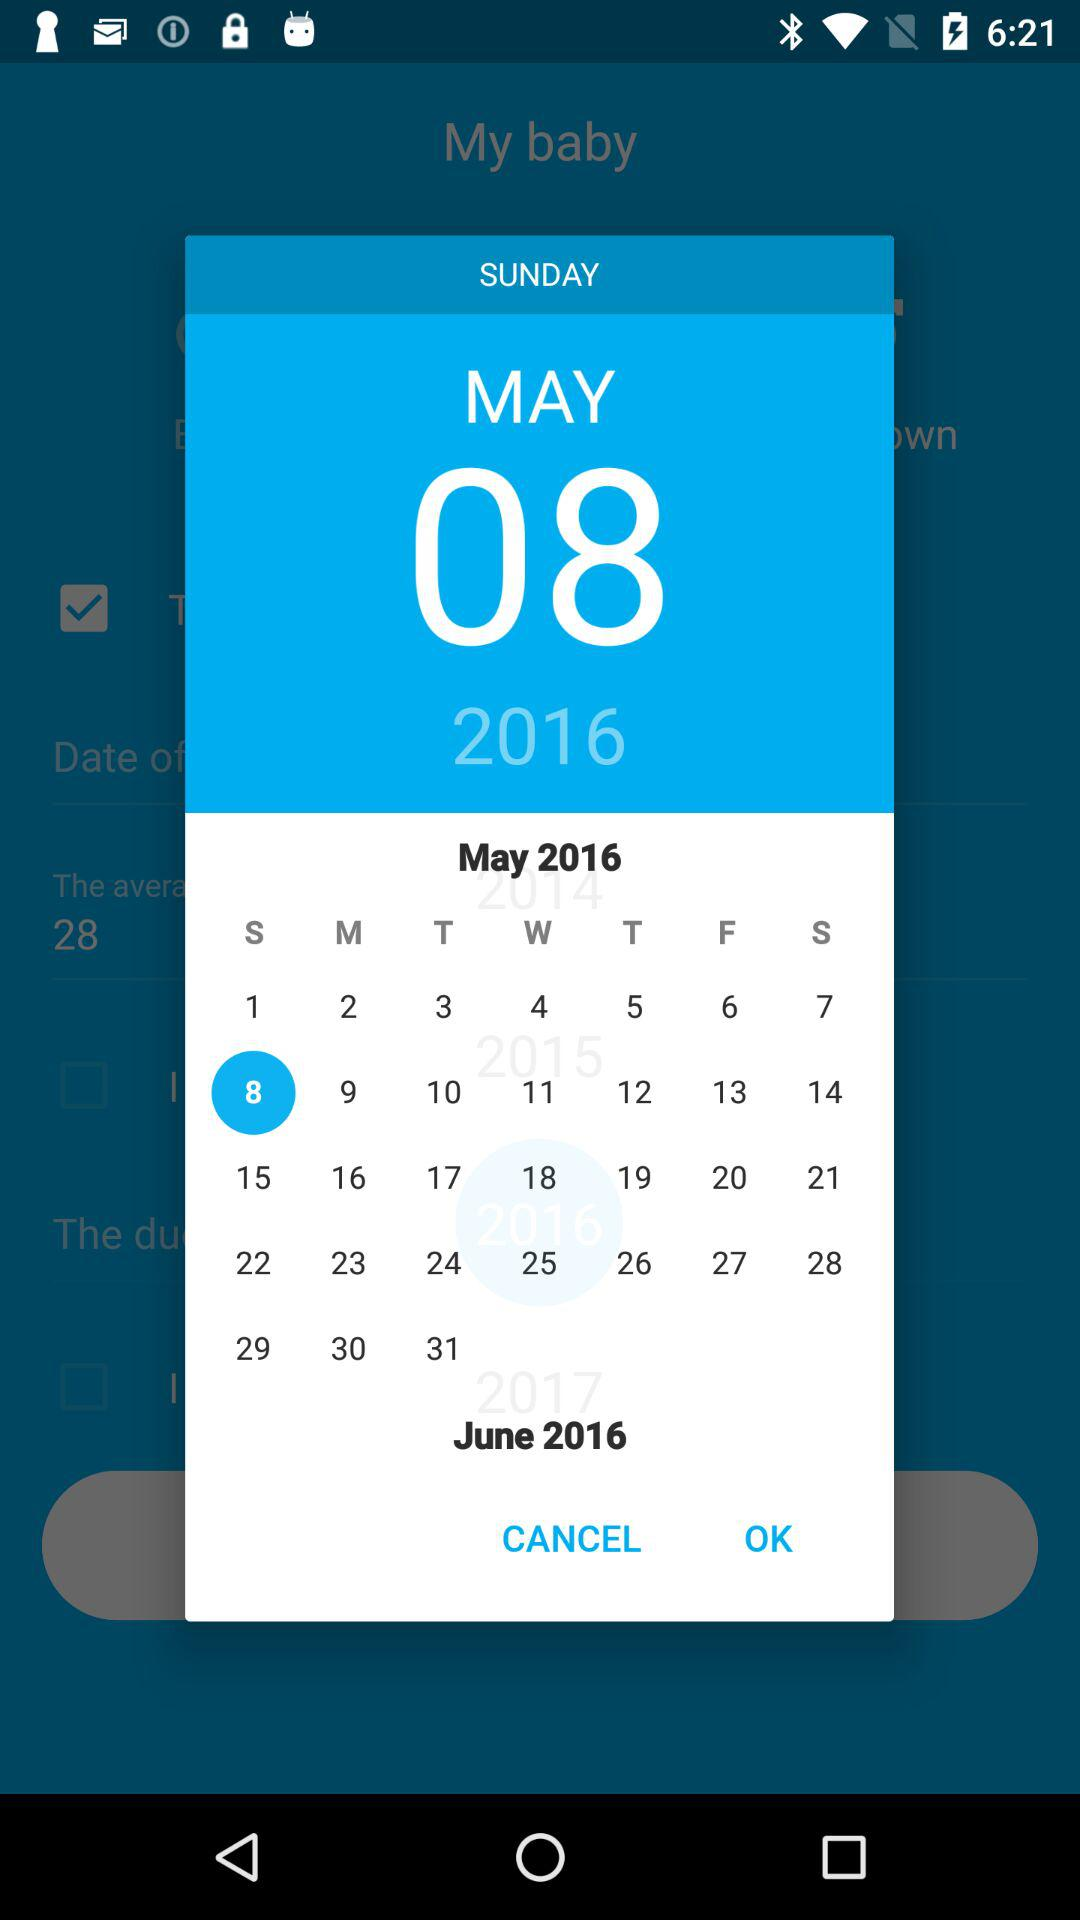What date is selected? The selected date is Sunday, May 8, 2016. 